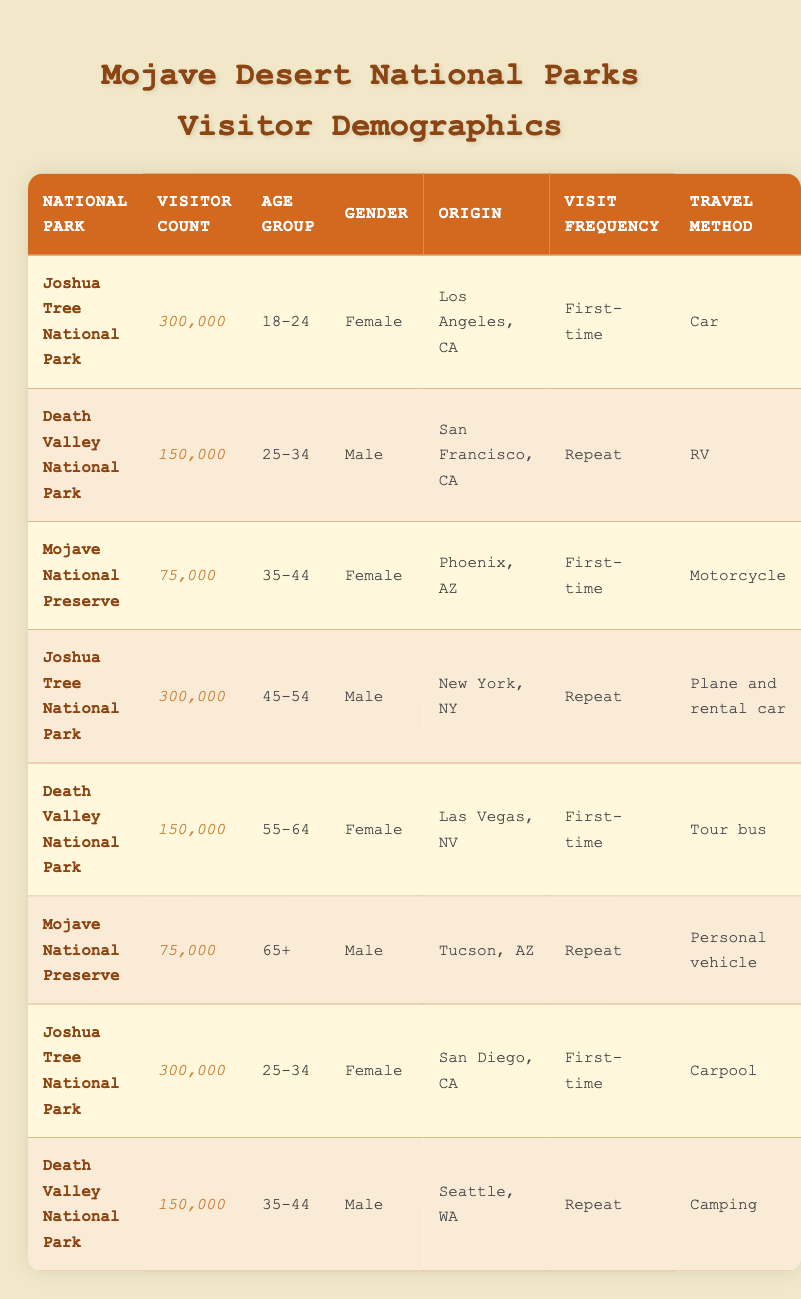What is the total number of visitors to Joshua Tree National Park? The table shows that there are three entries for Joshua Tree National Park with visitor counts of 300,000 each. Therefore, the total number of visitors is calculated as 300,000 + 300,000 + 300,000 = 900,000.
Answer: 900,000 What is the visitor count for Death Valley National Park from campers? According to the table, only one entry for Death Valley National Park mentions camping as the travel method, and it has a visitor count of 150,000. Therefore, this is the answer.
Answer: 150,000 How many female visitors are first-time tourists to national parks in the Mojave Desert? The table shows two entries for first-time female visitors: one from Los Angeles to Joshua Tree National Park and one from Las Vegas to Death Valley National Park. Their counts are 300,000 and 150,000 respectively, so the total is 300,000 + 150,000 = 450,000.
Answer: 450,000 Which age group has the highest number of visitors across all parks? To determine the age group with the highest visitor count, we need to sum up visitor counts for each age group from all parks. The counts are: 18-24 (300,000), 25-34 (300,000 + 300,000), 35-44 (75,000 + 150,000), 45-54 (300,000), 55-64 (150,000), and 65+ (75,000). The sums lead to: 18-24 = 300,000, 25-34 = 600,000, 35-44 = 225,000, 45-54 = 300,000, 55-64 = 150,000, and 65+ = 75,000. The highest count is for the age group 25-34 with 600,000 visitors.
Answer: 25-34 Is there a male visitor over 65 years old in the Mojave National Preserve? The table indicates there is one entry for the Mojave National Preserve with a visitor count of 75,000 who is male and over 65 years old. Therefore, the answer is yes.
Answer: Yes What is the difference in visitor counts between the two national parks with 150,000 visitors? The table shows Death Valley National Park with a visitor count of 150,000, and has a second entry for the same park, yielding the same number. Hence, the difference is calculated as 150,000 - 150,000 = 0.
Answer: 0 What is the percentage of first-time visitors to Mojave National Preserve? From the table, there are a total of 75,000 visitors to Mojave National Preserve, with two entries consisting of one for a first-time visitor and one for a repeat visitor (both male, one aged 35-44 and the other aged 65+). The count of first-time visitors is 75,000 out of the total 75,000, leading to the percentage being (75,000 / 75,000) * 100% = 100%.
Answer: 100% Are there more visitors from Las Vegas, NV, or Tucson, AZ? The table lists 150,000 visitors from Las Vegas (Death Valley National Park) and 75,000 visitors from Tucson (Mojave National Preserve). Hence, 150,000 > 75,000, indicating more visitors from Las Vegas. Thus, the answer is Las Vegas.
Answer: Las Vegas 